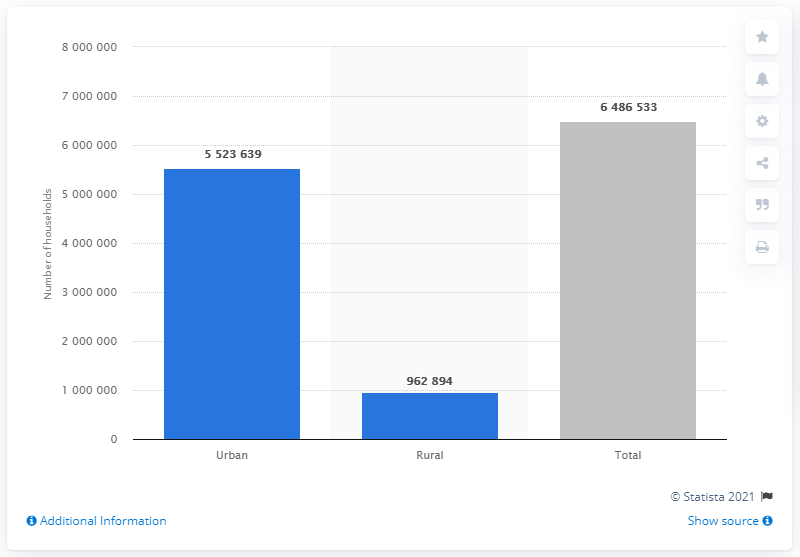How many of Chile's 6.5 million households are located in urban areas? According to the depicted data, 5,523,639 of Chile's households are located in urban areas. This represents a significant majority of the total households, highlighting the urban concentration in the country. 